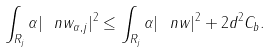Convert formula to latex. <formula><loc_0><loc_0><loc_500><loc_500>\int _ { R _ { j } } \alpha | \ n w _ { \alpha , j } | ^ { 2 } \leq \int _ { R _ { j } } \alpha | \ n w | ^ { 2 } + 2 d ^ { 2 } C _ { b } .</formula> 